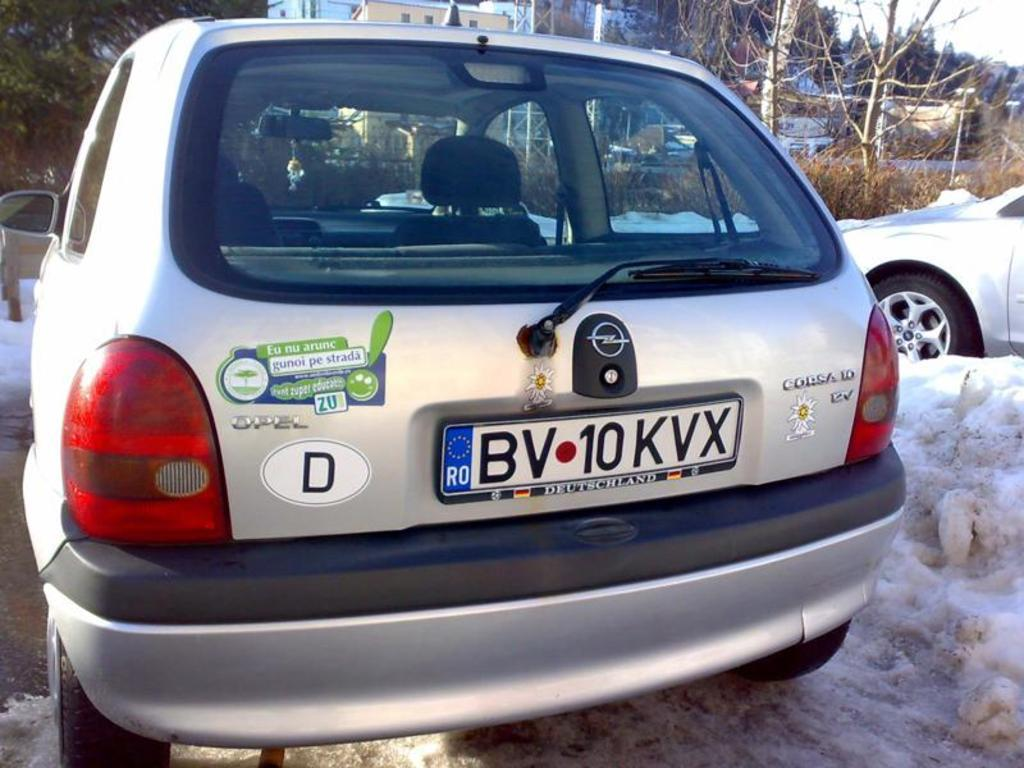<image>
Present a compact description of the photo's key features. a corsa 10 has several bumber stickers on the back 